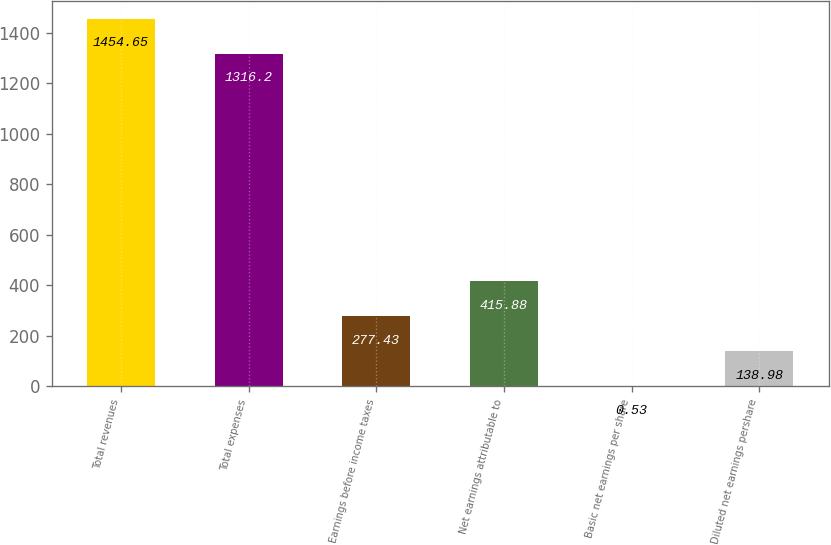Convert chart to OTSL. <chart><loc_0><loc_0><loc_500><loc_500><bar_chart><fcel>Total revenues<fcel>Total expenses<fcel>Earnings before income taxes<fcel>Net earnings attributable to<fcel>Basic net earnings per share<fcel>Diluted net earnings pershare<nl><fcel>1454.65<fcel>1316.2<fcel>277.43<fcel>415.88<fcel>0.53<fcel>138.98<nl></chart> 